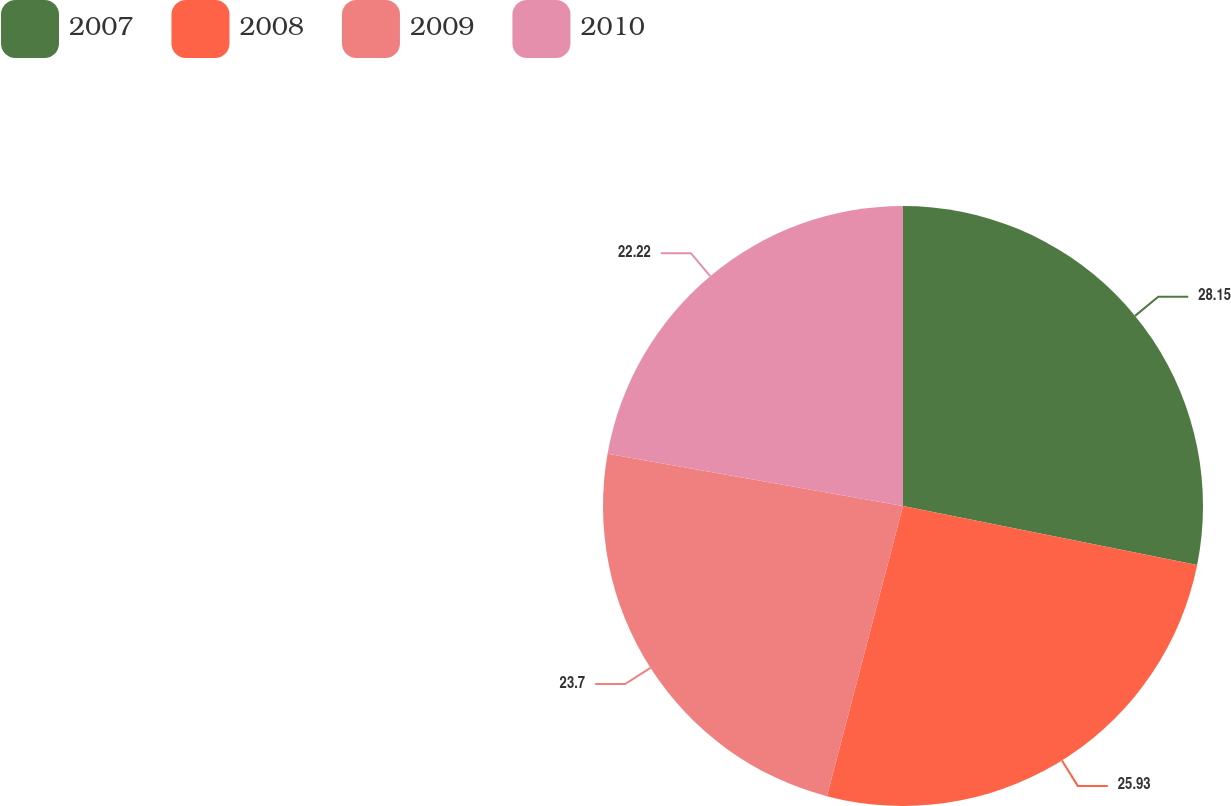Convert chart to OTSL. <chart><loc_0><loc_0><loc_500><loc_500><pie_chart><fcel>2007<fcel>2008<fcel>2009<fcel>2010<nl><fcel>28.15%<fcel>25.93%<fcel>23.7%<fcel>22.22%<nl></chart> 